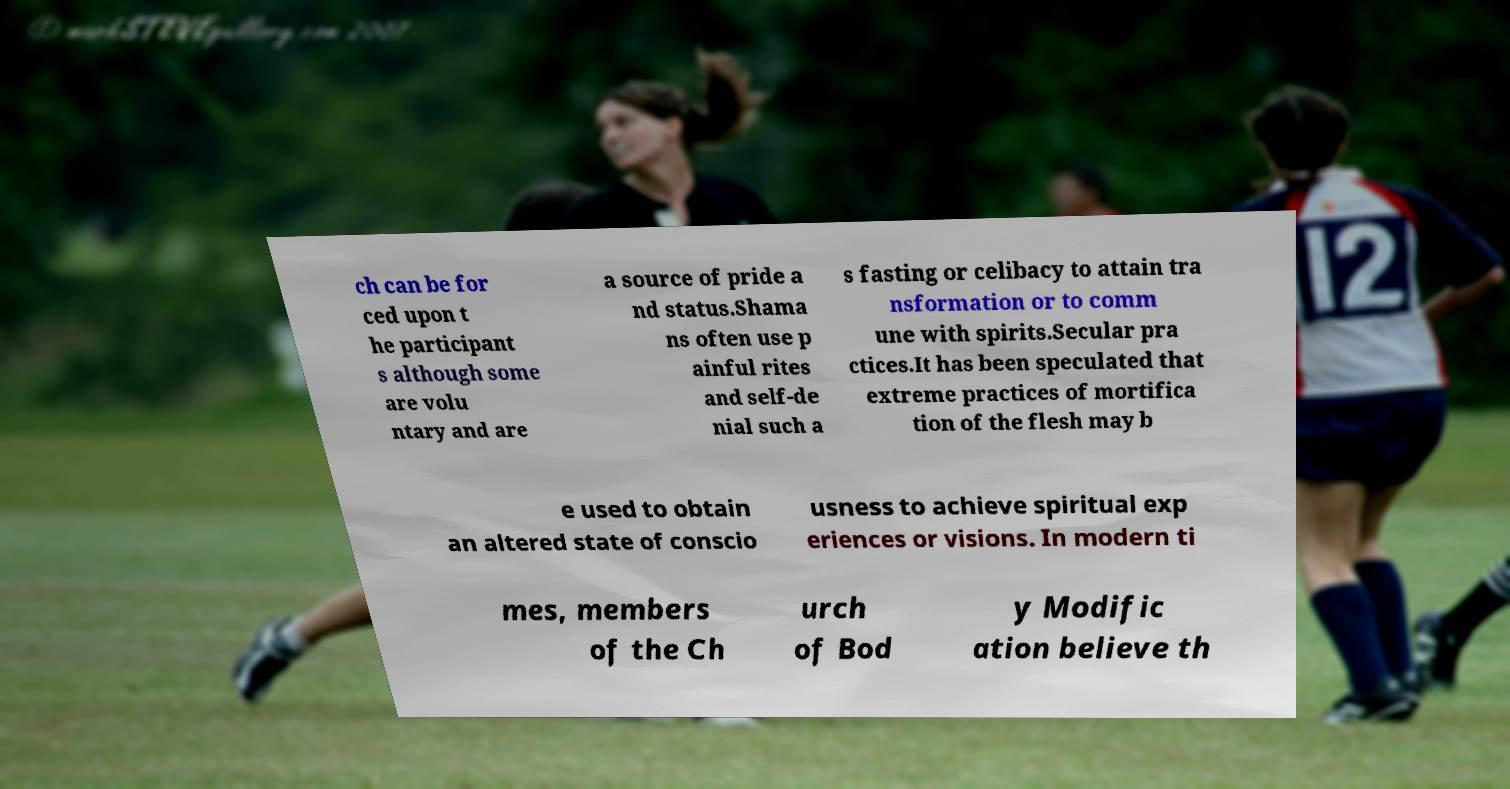For documentation purposes, I need the text within this image transcribed. Could you provide that? ch can be for ced upon t he participant s although some are volu ntary and are a source of pride a nd status.Shama ns often use p ainful rites and self-de nial such a s fasting or celibacy to attain tra nsformation or to comm une with spirits.Secular pra ctices.It has been speculated that extreme practices of mortifica tion of the flesh may b e used to obtain an altered state of conscio usness to achieve spiritual exp eriences or visions. In modern ti mes, members of the Ch urch of Bod y Modific ation believe th 